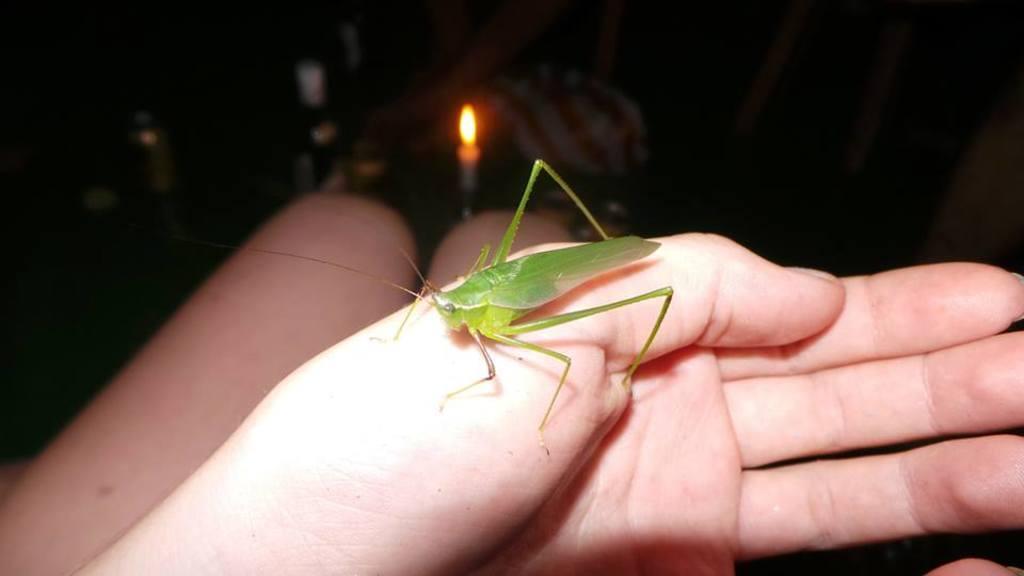Describe this image in one or two sentences. In this image I can see two legs and a hand of a person. I can also see a grasshopper on the hand. In the background I can see few bottles and a candle. 